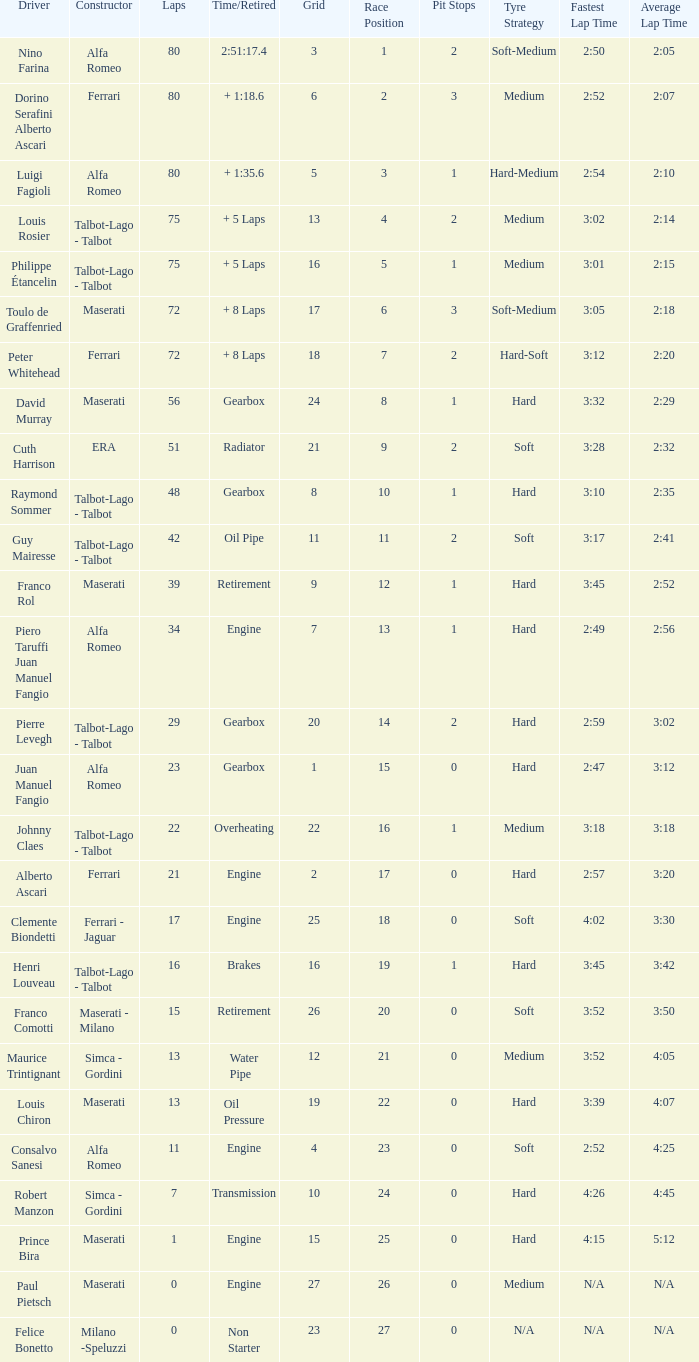What was the smallest grid for Prince bira? 15.0. 